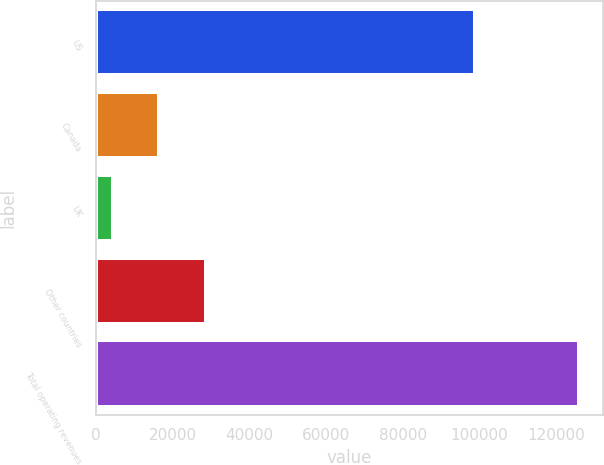Convert chart to OTSL. <chart><loc_0><loc_0><loc_500><loc_500><bar_chart><fcel>US<fcel>Canada<fcel>UK<fcel>Other countries<fcel>Total operating revenues<nl><fcel>98806<fcel>16466<fcel>4297<fcel>28635<fcel>125987<nl></chart> 